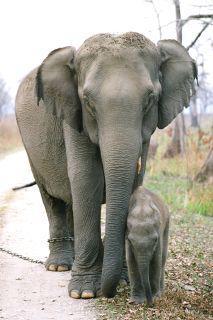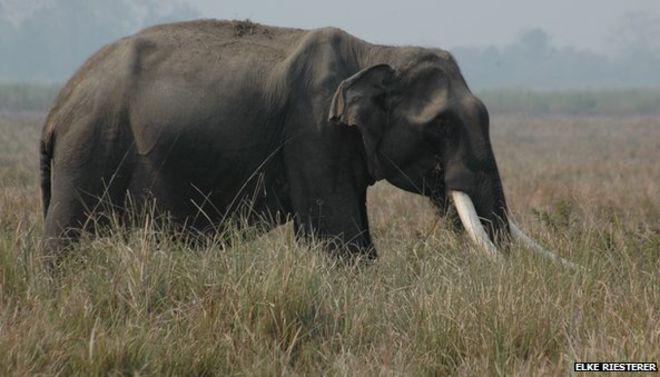The first image is the image on the left, the second image is the image on the right. For the images shown, is this caption "One image shows only an adult elephant interacting with a young elephant while the other image shows a single elephant." true? Answer yes or no. Yes. The first image is the image on the left, the second image is the image on the right. Considering the images on both sides, is "An image shows one baby elephant standing by one adult elephant on dry land." valid? Answer yes or no. Yes. 